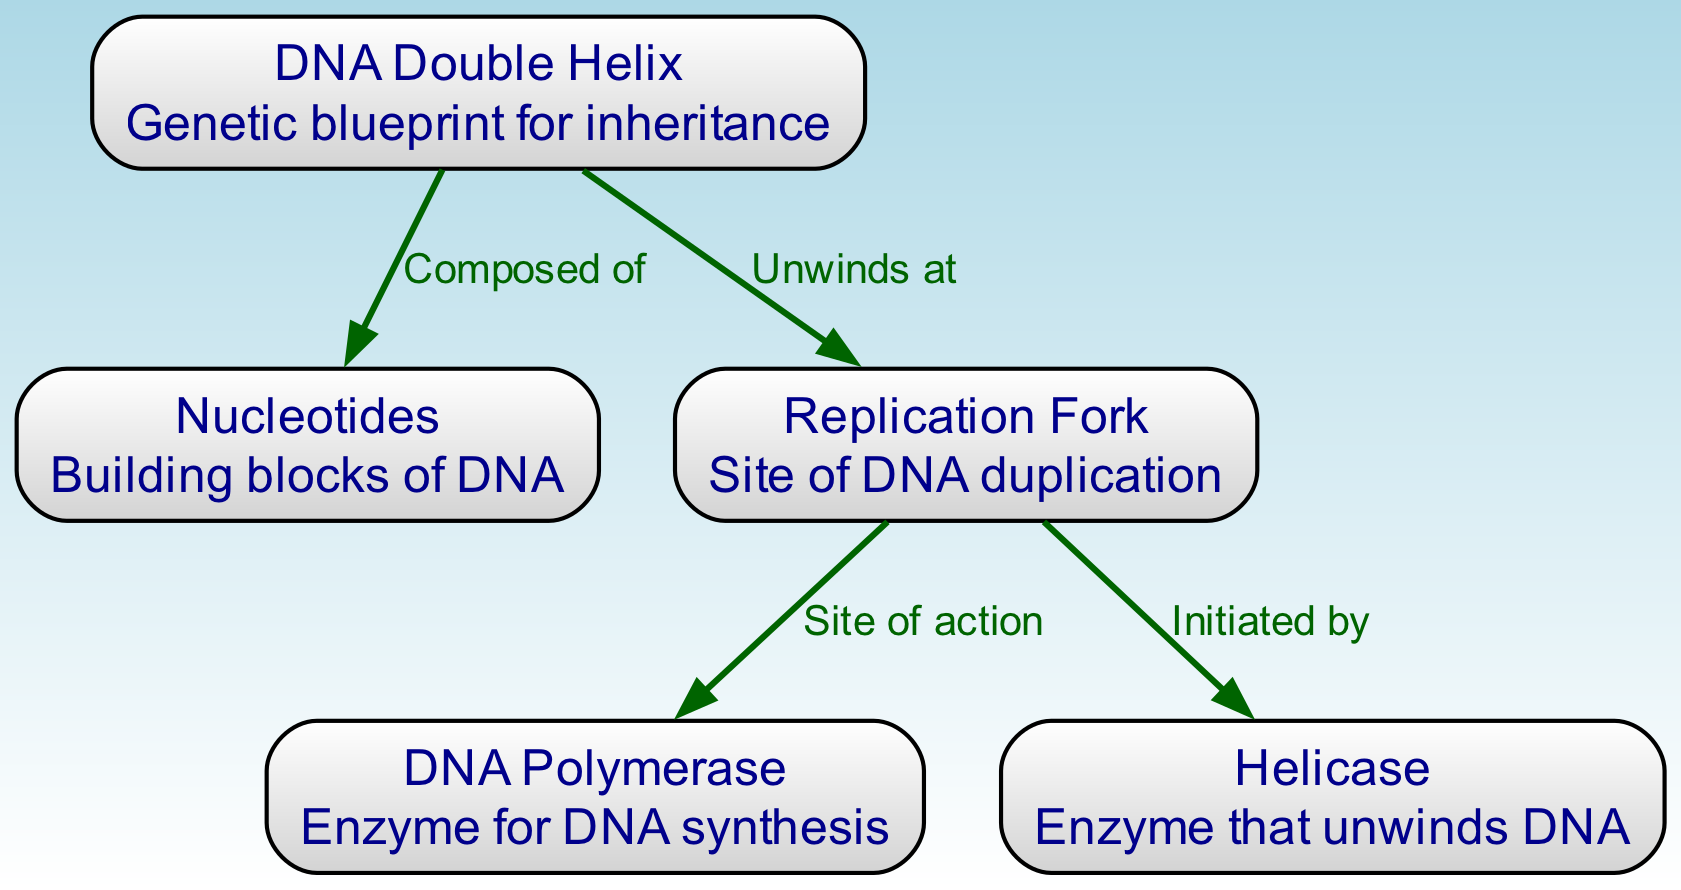What is the shape of the DNA structure? The diagram describes the DNA structure as a "Double Helix," which is a characteristic feature of DNA. This can be found in the node labeled "DNA Double Helix."
Answer: Double Helix How many nodes are present in the diagram? The diagram includes five nodes: DNA Double Helix, Nucleotides, Replication Fork, DNA Polymerase, and Helicase. Counting these nodes gives a total of five.
Answer: 5 What is the role of Helicase in DNA replication? The diagram indicates that Helicase is the enzyme that unwinds DNA, as noted in the description of the node "Helicase."
Answer: Unwinds DNA What does the Replication Fork connect to? The Replication Fork is connected to two nodes: DNA Polymerase and Helicase. This is indicated by the edges drawn from the "Replication Fork" node to those two nodes.
Answer: DNA Polymerase and Helicase What is the function of DNA Polymerase? The description for DNA Polymerase in the diagram states that it is the enzyme responsible for DNA synthesis, highlighting its key role in the replication process.
Answer: DNA synthesis Which node represents the building blocks of DNA? The node labeled "Nucleotides" clearly states that they are the building blocks of DNA, making it evident which node corresponds to this function.
Answer: Nucleotides What is initiated by the Replication Fork? According to the diagram, the Replication Fork initiates the action of Helicase, which is essential for the unwinding of the DNA during replication.
Answer: Helicase Which enzyme acts at the site of the Replication Fork? The diagram identifies DNA Polymerase as the enzyme that operates at the site of the Replication Fork, as described in the edge that connects these two nodes.
Answer: DNA Polymerase How does the DNA Double Helix relate to Nucleotides? The relationship is defined in the diagram where the edge indicates that the DNA Double Helix is composed of Nucleotides, showing the foundational structure of DNA.
Answer: Composed of 